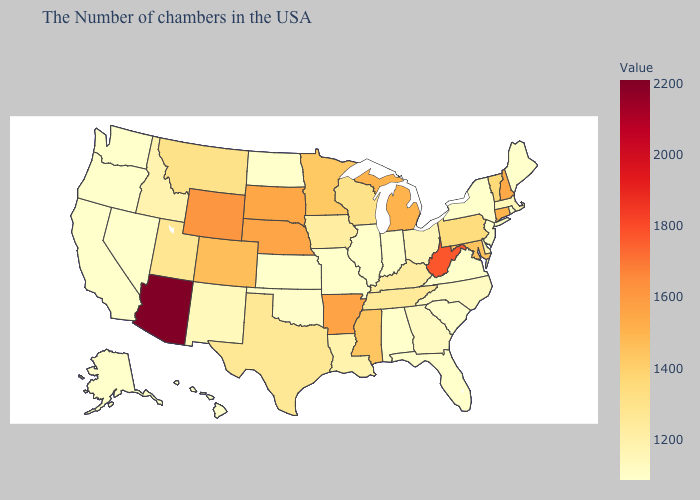Which states hav the highest value in the MidWest?
Be succinct. Nebraska. Which states have the lowest value in the Northeast?
Give a very brief answer. Maine, Rhode Island, New York, New Jersey. Does North Carolina have the highest value in the South?
Answer briefly. No. Which states hav the highest value in the South?
Give a very brief answer. West Virginia. Which states have the lowest value in the MidWest?
Short answer required. Indiana, Illinois, Missouri, Kansas, North Dakota. 